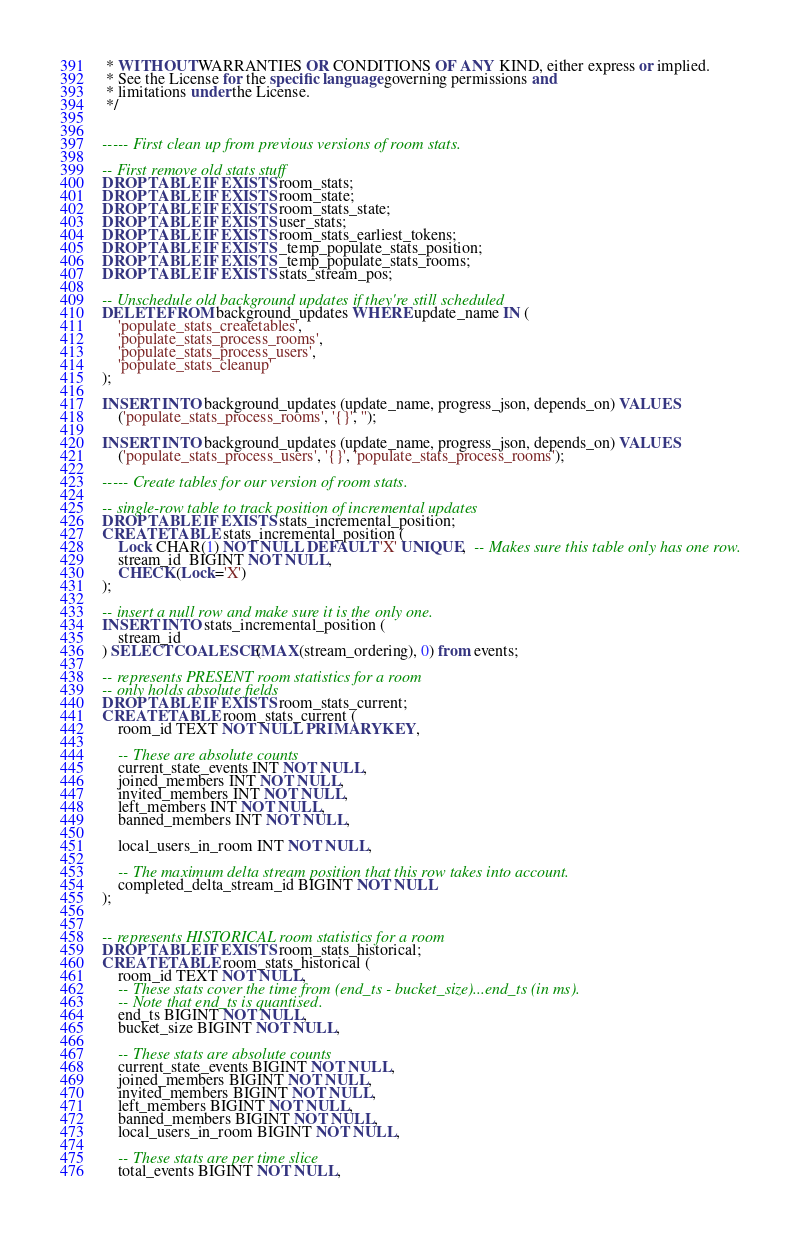<code> <loc_0><loc_0><loc_500><loc_500><_SQL_> * WITHOUT WARRANTIES OR CONDITIONS OF ANY KIND, either express or implied.
 * See the License for the specific language governing permissions and
 * limitations under the License.
 */


----- First clean up from previous versions of room stats.

-- First remove old stats stuff
DROP TABLE IF EXISTS room_stats;
DROP TABLE IF EXISTS room_state;
DROP TABLE IF EXISTS room_stats_state;
DROP TABLE IF EXISTS user_stats;
DROP TABLE IF EXISTS room_stats_earliest_tokens;
DROP TABLE IF EXISTS _temp_populate_stats_position;
DROP TABLE IF EXISTS _temp_populate_stats_rooms;
DROP TABLE IF EXISTS stats_stream_pos;

-- Unschedule old background updates if they're still scheduled
DELETE FROM background_updates WHERE update_name IN (
    'populate_stats_createtables',
    'populate_stats_process_rooms',
    'populate_stats_process_users',
    'populate_stats_cleanup'
);

INSERT INTO background_updates (update_name, progress_json, depends_on) VALUES
    ('populate_stats_process_rooms', '{}', '');

INSERT INTO background_updates (update_name, progress_json, depends_on) VALUES
    ('populate_stats_process_users', '{}', 'populate_stats_process_rooms');

----- Create tables for our version of room stats.

-- single-row table to track position of incremental updates
DROP TABLE IF EXISTS stats_incremental_position;
CREATE TABLE stats_incremental_position (
    Lock CHAR(1) NOT NULL DEFAULT 'X' UNIQUE,  -- Makes sure this table only has one row.
    stream_id  BIGINT NOT NULL,
    CHECK (Lock='X')
);

-- insert a null row and make sure it is the only one.
INSERT INTO stats_incremental_position (
    stream_id
) SELECT COALESCE(MAX(stream_ordering), 0) from events;

-- represents PRESENT room statistics for a room
-- only holds absolute fields
DROP TABLE IF EXISTS room_stats_current;
CREATE TABLE room_stats_current (
    room_id TEXT NOT NULL PRIMARY KEY,

    -- These are absolute counts
    current_state_events INT NOT NULL,
    joined_members INT NOT NULL,
    invited_members INT NOT NULL,
    left_members INT NOT NULL,
    banned_members INT NOT NULL,

    local_users_in_room INT NOT NULL,

    -- The maximum delta stream position that this row takes into account.
    completed_delta_stream_id BIGINT NOT NULL
);


-- represents HISTORICAL room statistics for a room
DROP TABLE IF EXISTS room_stats_historical;
CREATE TABLE room_stats_historical (
    room_id TEXT NOT NULL,
    -- These stats cover the time from (end_ts - bucket_size)...end_ts (in ms).
    -- Note that end_ts is quantised.
    end_ts BIGINT NOT NULL,
    bucket_size BIGINT NOT NULL,

    -- These stats are absolute counts
    current_state_events BIGINT NOT NULL,
    joined_members BIGINT NOT NULL,
    invited_members BIGINT NOT NULL,
    left_members BIGINT NOT NULL,
    banned_members BIGINT NOT NULL,
    local_users_in_room BIGINT NOT NULL,

    -- These stats are per time slice
    total_events BIGINT NOT NULL,</code> 